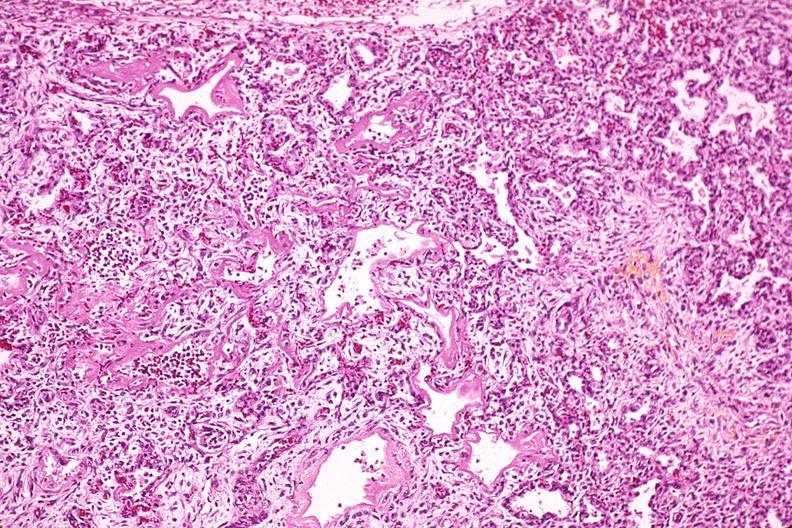what is present?
Answer the question using a single word or phrase. Respiratory 